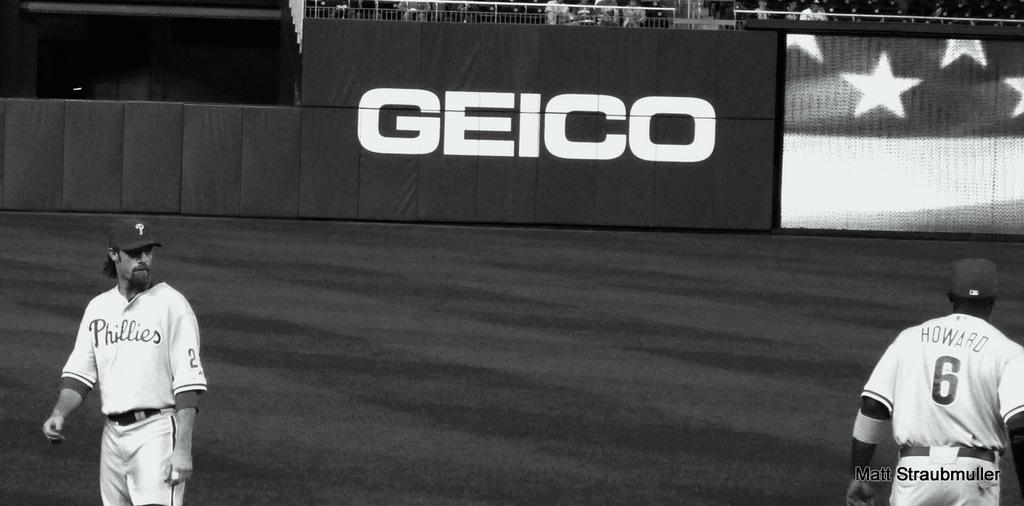<image>
Offer a succinct explanation of the picture presented. Two baseball players standing on the field sponsored by GEICO. 